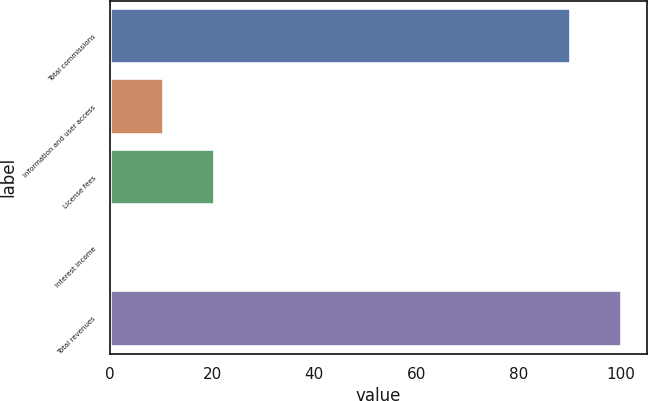<chart> <loc_0><loc_0><loc_500><loc_500><bar_chart><fcel>Total commissions<fcel>Information and user access<fcel>License fees<fcel>Interest income<fcel>Total revenues<nl><fcel>90.3<fcel>10.54<fcel>20.48<fcel>0.6<fcel>100.24<nl></chart> 